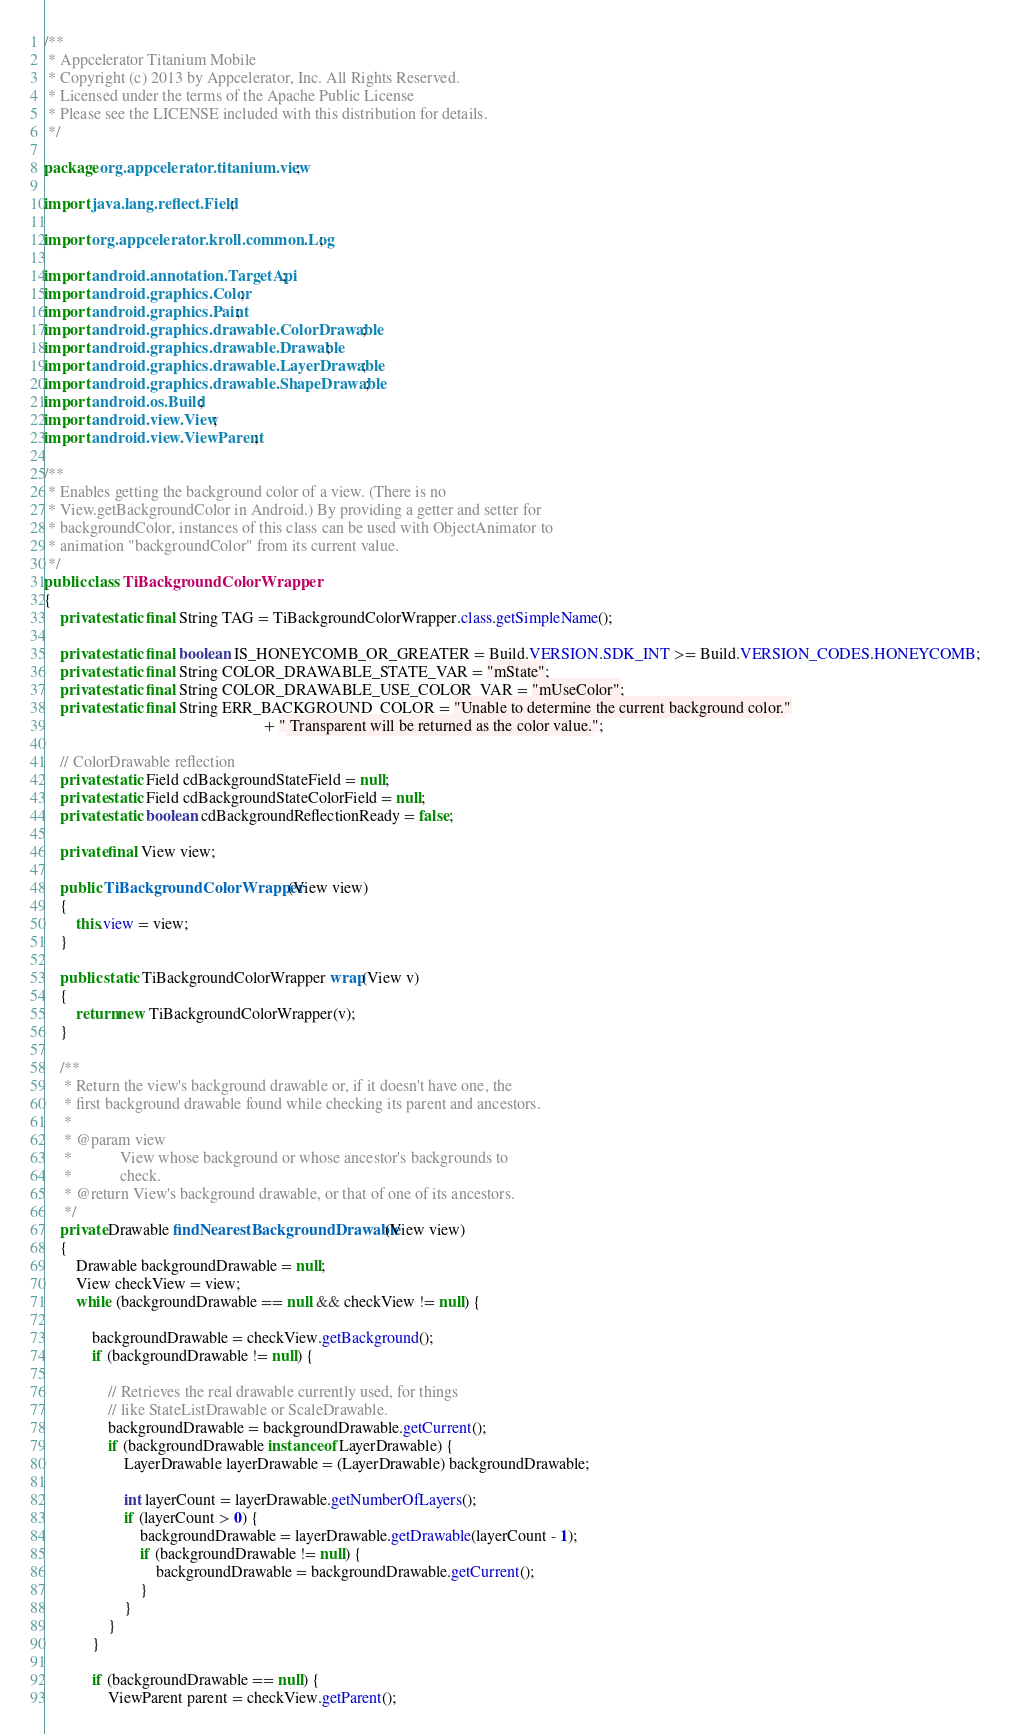<code> <loc_0><loc_0><loc_500><loc_500><_Java_>/**
 * Appcelerator Titanium Mobile
 * Copyright (c) 2013 by Appcelerator, Inc. All Rights Reserved.
 * Licensed under the terms of the Apache Public License
 * Please see the LICENSE included with this distribution for details.
 */

package org.appcelerator.titanium.view;

import java.lang.reflect.Field;

import org.appcelerator.kroll.common.Log;

import android.annotation.TargetApi;
import android.graphics.Color;
import android.graphics.Paint;
import android.graphics.drawable.ColorDrawable;
import android.graphics.drawable.Drawable;
import android.graphics.drawable.LayerDrawable;
import android.graphics.drawable.ShapeDrawable;
import android.os.Build;
import android.view.View;
import android.view.ViewParent;

/**
 * Enables getting the background color of a view. (There is no
 * View.getBackgroundColor in Android.) By providing a getter and setter for
 * backgroundColor, instances of this class can be used with ObjectAnimator to
 * animation "backgroundColor" from its current value.
 */
public class TiBackgroundColorWrapper
{
	private static final String TAG = TiBackgroundColorWrapper.class.getSimpleName();

	private static final boolean IS_HONEYCOMB_OR_GREATER = Build.VERSION.SDK_INT >= Build.VERSION_CODES.HONEYCOMB;
	private static final String COLOR_DRAWABLE_STATE_VAR = "mState";
	private static final String COLOR_DRAWABLE_USE_COLOR_VAR = "mUseColor";
	private static final String ERR_BACKGROUND_COLOR = "Unable to determine the current background color."
													   + " Transparent will be returned as the color value.";

	// ColorDrawable reflection
	private static Field cdBackgroundStateField = null;
	private static Field cdBackgroundStateColorField = null;
	private static boolean cdBackgroundReflectionReady = false;

	private final View view;

	public TiBackgroundColorWrapper(View view)
	{
		this.view = view;
	}

	public static TiBackgroundColorWrapper wrap(View v)
	{
		return new TiBackgroundColorWrapper(v);
	}

	/**
	 * Return the view's background drawable or, if it doesn't have one, the
	 * first background drawable found while checking its parent and ancestors.
	 *
	 * @param view
	 *            View whose background or whose ancestor's backgrounds to
	 *            check.
	 * @return View's background drawable, or that of one of its ancestors.
	 */
	private Drawable findNearestBackgroundDrawable(View view)
	{
		Drawable backgroundDrawable = null;
		View checkView = view;
		while (backgroundDrawable == null && checkView != null) {

			backgroundDrawable = checkView.getBackground();
			if (backgroundDrawable != null) {

				// Retrieves the real drawable currently used, for things
				// like StateListDrawable or ScaleDrawable.
				backgroundDrawable = backgroundDrawable.getCurrent();
				if (backgroundDrawable instanceof LayerDrawable) {
					LayerDrawable layerDrawable = (LayerDrawable) backgroundDrawable;

					int layerCount = layerDrawable.getNumberOfLayers();
					if (layerCount > 0) {
						backgroundDrawable = layerDrawable.getDrawable(layerCount - 1);
						if (backgroundDrawable != null) {
							backgroundDrawable = backgroundDrawable.getCurrent();
						}
					}
				}
			}

			if (backgroundDrawable == null) {
				ViewParent parent = checkView.getParent();</code> 